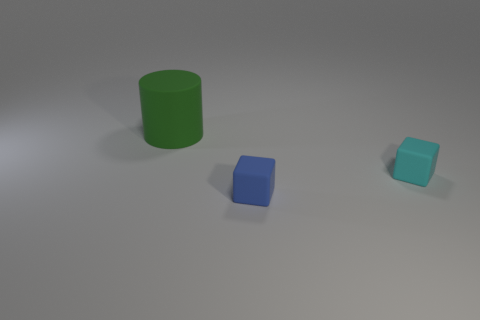Add 2 cyan cubes. How many objects exist? 5 Subtract 1 cylinders. How many cylinders are left? 0 Subtract all cyan blocks. How many blocks are left? 1 Subtract all blocks. How many objects are left? 1 Subtract all purple balls. How many gray cubes are left? 0 Subtract all tiny brown metal cylinders. Subtract all blue rubber things. How many objects are left? 2 Add 3 rubber cubes. How many rubber cubes are left? 5 Add 1 small brown rubber cylinders. How many small brown rubber cylinders exist? 1 Subtract 1 blue cubes. How many objects are left? 2 Subtract all blue blocks. Subtract all brown cylinders. How many blocks are left? 1 